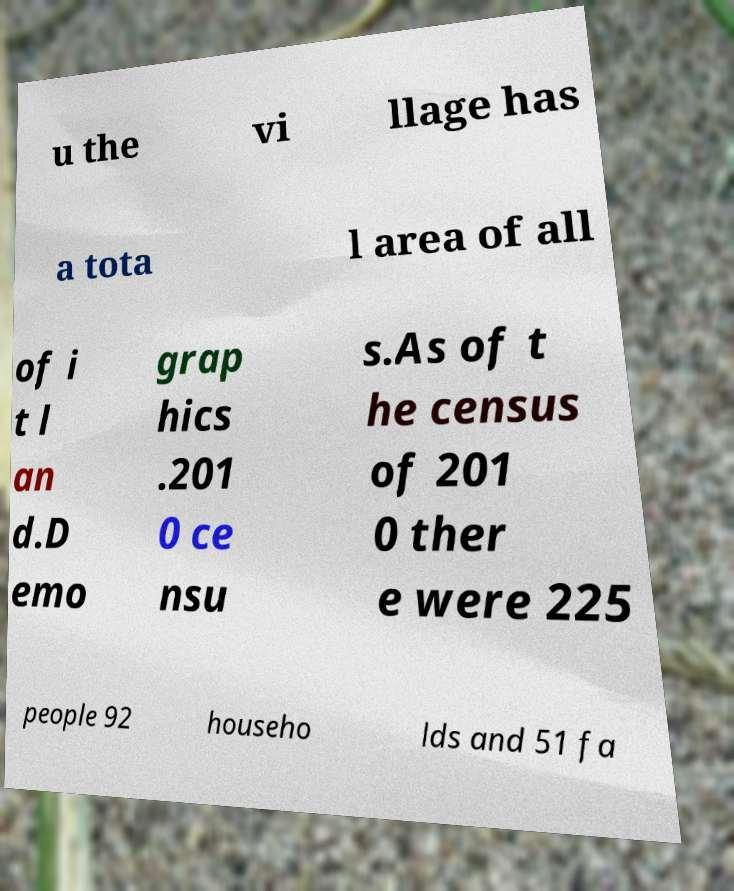Could you assist in decoding the text presented in this image and type it out clearly? u the vi llage has a tota l area of all of i t l an d.D emo grap hics .201 0 ce nsu s.As of t he census of 201 0 ther e were 225 people 92 househo lds and 51 fa 